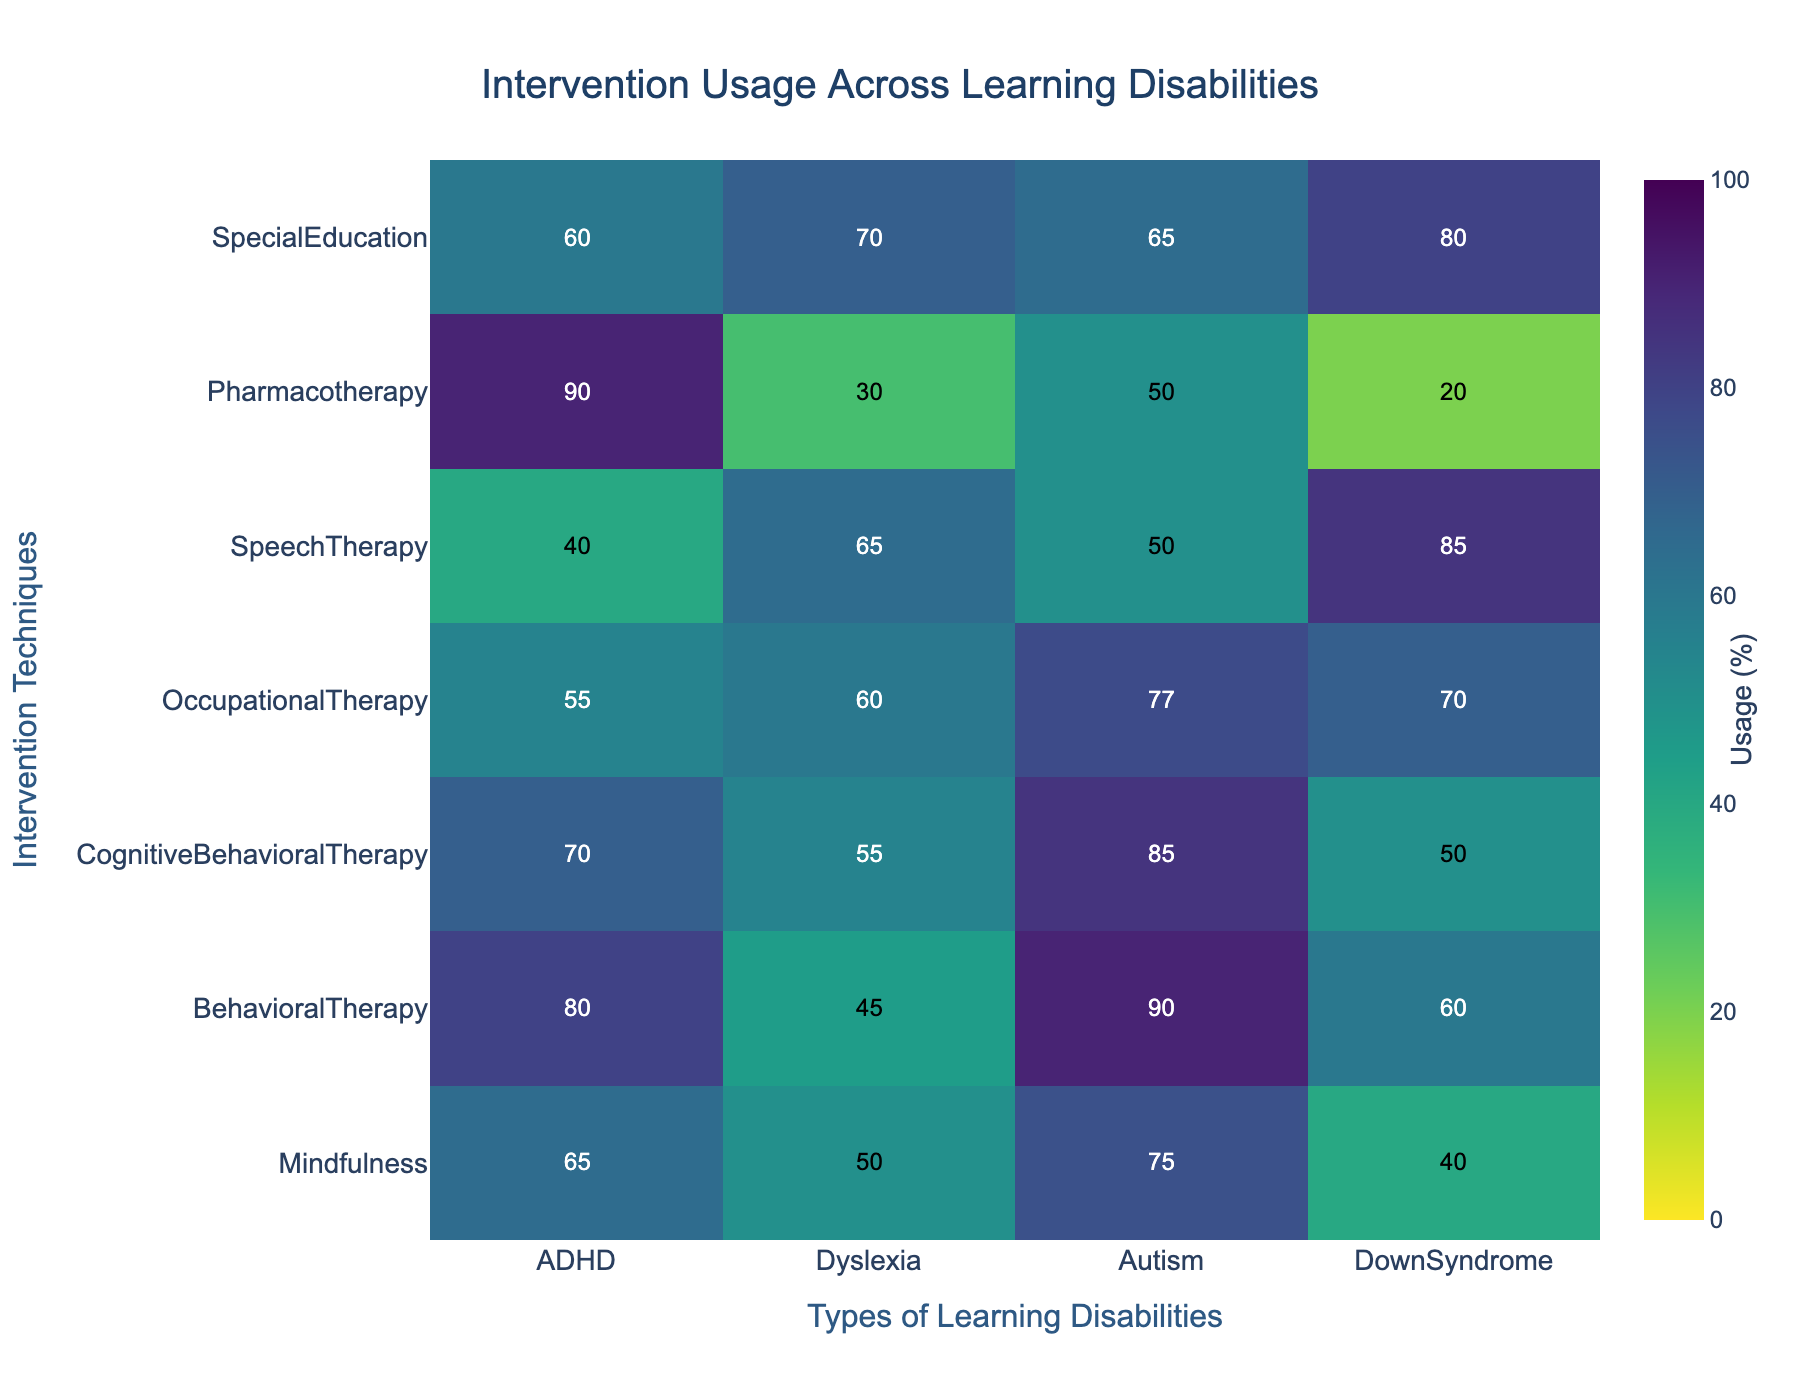What is the title of the figure? The title is usually located at the top of the figure. According to the given code, the title is set to be 'Intervention Usage Across Learning Disabilities'.
Answer: Intervention Usage Across Learning Disabilities Which intervention technique has the highest usage percentage for ADHD? In the heatmap, find the column corresponding to ADHD and look for the highest value within that column. The highest value is 90, associated with Pharmacotherapy.
Answer: Pharmacotherapy How many intervention techniques are evaluated in the figure? The number of intervention techniques can be counted from the y-axis. There are seven rows, each representing a different intervention technique.
Answer: 7 What is the average usage of Mindfulness across all learning disabilities? Find the row corresponding to Mindfulness and calculate the average of its values: (65 + 50 + 75 + 40) / 4 = 57.5.
Answer: 57.5 Which learning disability has the least usage of Speech Therapy? In the column for Speech Therapy, identify the smallest value. The smallest value in that row is 40, which is associated with ADHD.
Answer: ADHD Is the usage of Cognitive Behavioral Therapy for Autism higher or lower than for ADHD? Compare the values for Cognitive Behavioral Therapy in the Autism and ADHD columns. For Autism, the value is 85, and for ADHD, it is 70.
Answer: Higher Which learning disability shows the highest diversity in the usage percentage of intervention techniques? Examine the spread of values across each learning disability column and determine the one with the largest range (highest value - lowest value). For Autism, the range is (90 - 50) = 40, for ADHD (90 - 40) = 50, for Down Syndrome (85 - 20) = 65, and for Dyslexia (70 - 30) = 40. The highest range is found in Down Syndrome.
Answer: Down Syndrome Is Occupational Therapy more utilized for Autism or Down Syndrome? Compare the values for Occupational Therapy in the Autism and Down Syndrome columns. Autism has a value of 77 and Down Syndrome has a value of 70.
Answer: Autism What is the sum of the usage percentages of Special Education across all learning disabilities? Sum the values in the Special Education row: 60 + 70 + 65 + 80 = 275.
Answer: 275 Which intervention technique has the most balanced usage across all learning disabilities? Balanced usage implies similar values across all columns for an intervention. Occupational Therapy has values 55, 60, 77, 70, with a range of (77 - 55) = 22, which is the smallest range compared to others.
Answer: Occupational Therapy 